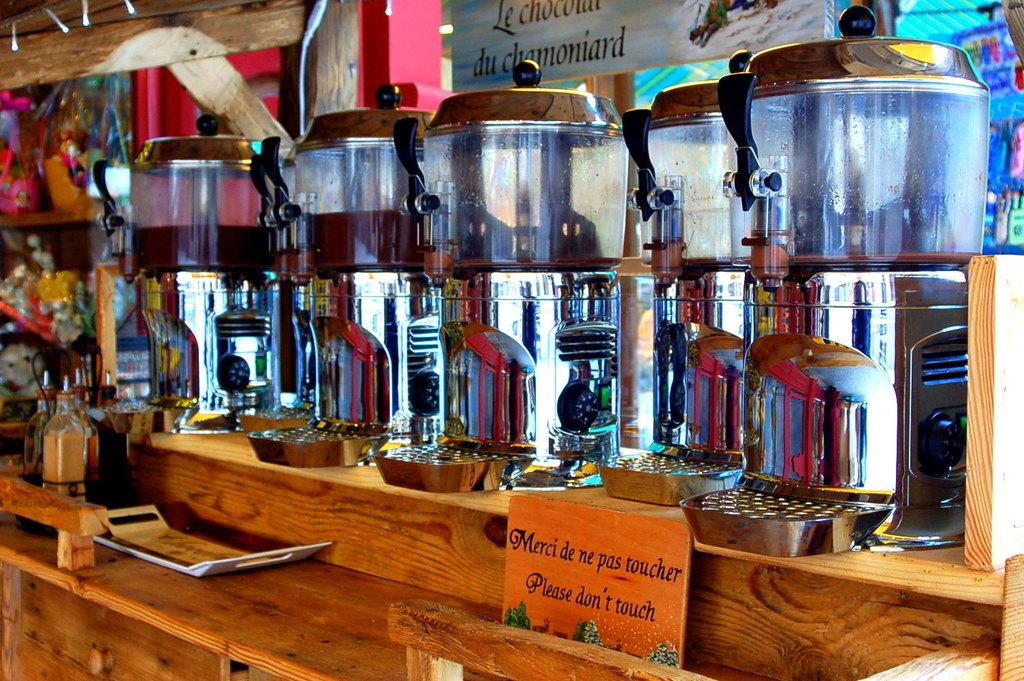What is instructed on the orange sign?
Provide a succinct answer. Please don't touch. 